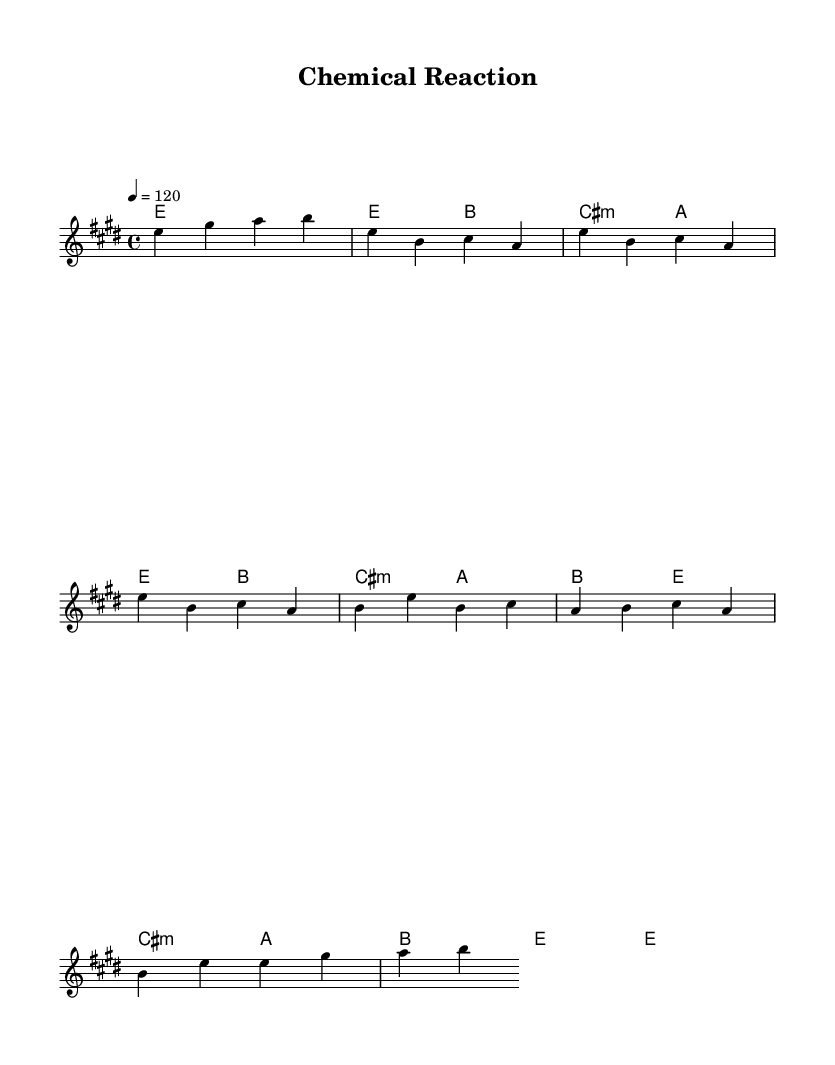What is the key signature of this music? The key signature is shown at the beginning of the piece. In this case, it indicates E major, which has four sharps: F#, C#, G#, and D#.
Answer: E major What is the time signature of this piece? The time signature appears in the first measures as a fraction, showing 4 beats per measure with a quarter note receiving one beat. This is indicated as 4/4.
Answer: 4/4 What is the tempo marking for this piece? The tempo marking is found at the beginning and indicates the speed of the piece. It shows 120 beats per minute, meaning there are 120 quarter note pulses each minute.
Answer: 120 How many measures are in the chorus? Counting the measures in the chorus section, there are a total of four measures that make up the chorus. This can be seen under the section labeled as Chorus.
Answer: 4 What harmony chord is used in the bridge section? Looking at the chord notations under the bridge, it indicates the use of a minor chord (cis minor) and then transitions to A major, and ends with E major.
Answer: cis minor What is the main thematic focus of the lyrics? The lyrics suggest a concentration on scientific endeavors, particularly in a lab setting, aiming towards advancements and satisfaction from chemical reactions. This is clear from the repeated phrases in the lyrics.
Answer: Scientific breakthroughs How is the solo section portrayed in relation to the rest of the piece? The solo section is indicated as a simplified version of the introductory melody. This suggests a prominent instrumental break that reuses thematic material from earlier, creating cohesion.
Answer: Instrumental break 